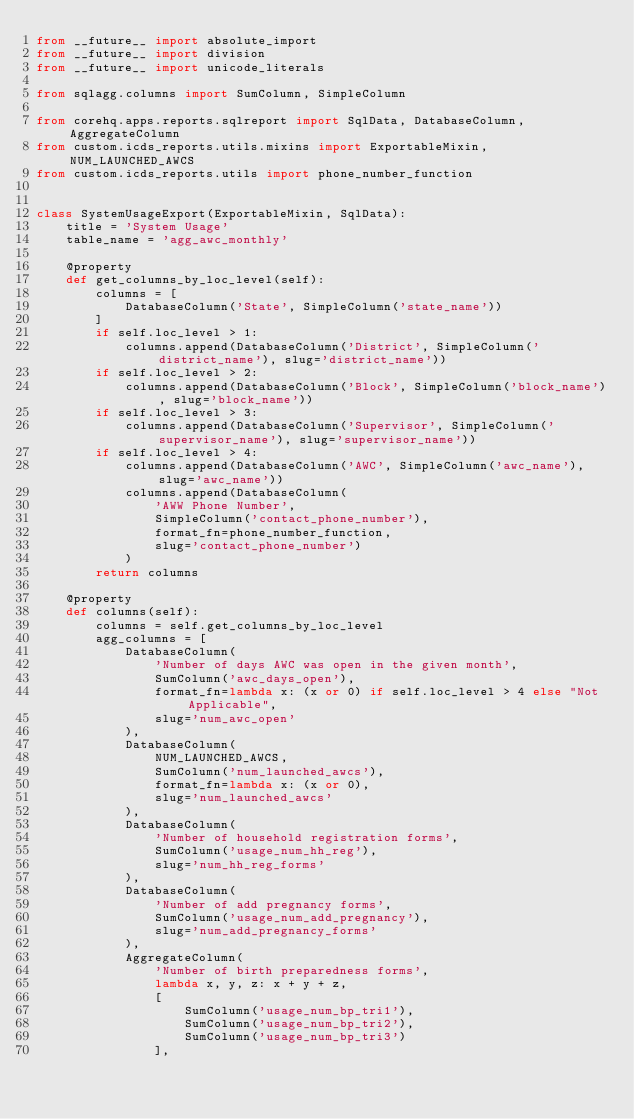<code> <loc_0><loc_0><loc_500><loc_500><_Python_>from __future__ import absolute_import
from __future__ import division
from __future__ import unicode_literals

from sqlagg.columns import SumColumn, SimpleColumn

from corehq.apps.reports.sqlreport import SqlData, DatabaseColumn, AggregateColumn
from custom.icds_reports.utils.mixins import ExportableMixin, NUM_LAUNCHED_AWCS
from custom.icds_reports.utils import phone_number_function


class SystemUsageExport(ExportableMixin, SqlData):
    title = 'System Usage'
    table_name = 'agg_awc_monthly'

    @property
    def get_columns_by_loc_level(self):
        columns = [
            DatabaseColumn('State', SimpleColumn('state_name'))
        ]
        if self.loc_level > 1:
            columns.append(DatabaseColumn('District', SimpleColumn('district_name'), slug='district_name'))
        if self.loc_level > 2:
            columns.append(DatabaseColumn('Block', SimpleColumn('block_name'), slug='block_name'))
        if self.loc_level > 3:
            columns.append(DatabaseColumn('Supervisor', SimpleColumn('supervisor_name'), slug='supervisor_name'))
        if self.loc_level > 4:
            columns.append(DatabaseColumn('AWC', SimpleColumn('awc_name'), slug='awc_name'))
            columns.append(DatabaseColumn(
                'AWW Phone Number',
                SimpleColumn('contact_phone_number'),
                format_fn=phone_number_function,
                slug='contact_phone_number')
            )
        return columns

    @property
    def columns(self):
        columns = self.get_columns_by_loc_level
        agg_columns = [
            DatabaseColumn(
                'Number of days AWC was open in the given month',
                SumColumn('awc_days_open'),
                format_fn=lambda x: (x or 0) if self.loc_level > 4 else "Not Applicable",
                slug='num_awc_open'
            ),
            DatabaseColumn(
                NUM_LAUNCHED_AWCS,
                SumColumn('num_launched_awcs'),
                format_fn=lambda x: (x or 0),
                slug='num_launched_awcs'
            ),
            DatabaseColumn(
                'Number of household registration forms',
                SumColumn('usage_num_hh_reg'),
                slug='num_hh_reg_forms'
            ),
            DatabaseColumn(
                'Number of add pregnancy forms',
                SumColumn('usage_num_add_pregnancy'),
                slug='num_add_pregnancy_forms'
            ),
            AggregateColumn(
                'Number of birth preparedness forms',
                lambda x, y, z: x + y + z,
                [
                    SumColumn('usage_num_bp_tri1'),
                    SumColumn('usage_num_bp_tri2'),
                    SumColumn('usage_num_bp_tri3')
                ],</code> 